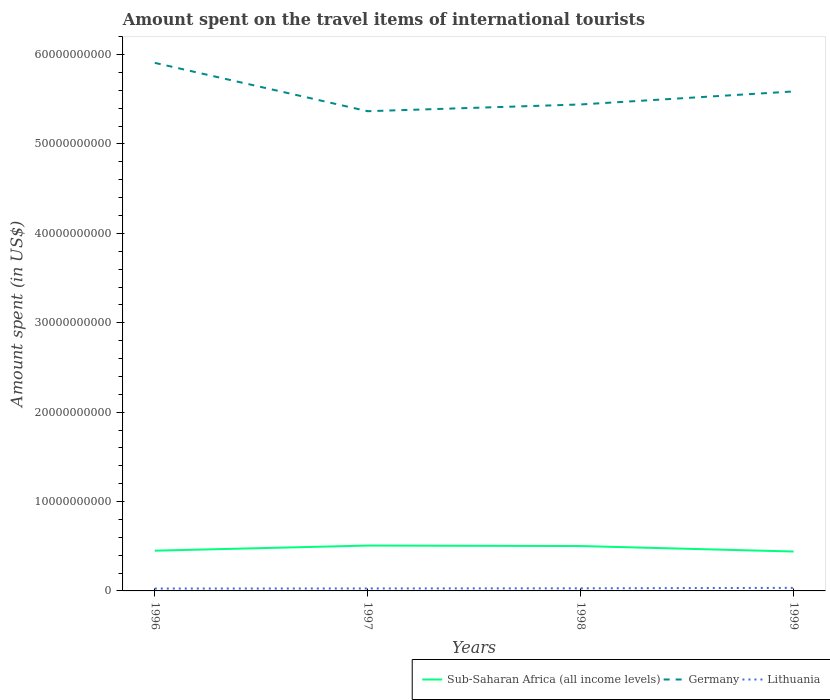Does the line corresponding to Sub-Saharan Africa (all income levels) intersect with the line corresponding to Lithuania?
Keep it short and to the point. No. Is the number of lines equal to the number of legend labels?
Keep it short and to the point. Yes. Across all years, what is the maximum amount spent on the travel items of international tourists in Sub-Saharan Africa (all income levels)?
Provide a short and direct response. 4.41e+09. What is the total amount spent on the travel items of international tourists in Germany in the graph?
Offer a terse response. 4.65e+09. What is the difference between the highest and the second highest amount spent on the travel items of international tourists in Sub-Saharan Africa (all income levels)?
Offer a terse response. 6.65e+08. Is the amount spent on the travel items of international tourists in Sub-Saharan Africa (all income levels) strictly greater than the amount spent on the travel items of international tourists in Germany over the years?
Offer a very short reply. Yes. How many lines are there?
Ensure brevity in your answer.  3. What is the title of the graph?
Give a very brief answer. Amount spent on the travel items of international tourists. What is the label or title of the Y-axis?
Your answer should be compact. Amount spent (in US$). What is the Amount spent (in US$) in Sub-Saharan Africa (all income levels) in 1996?
Keep it short and to the point. 4.50e+09. What is the Amount spent (in US$) in Germany in 1996?
Offer a terse response. 5.91e+1. What is the Amount spent (in US$) of Lithuania in 1996?
Your response must be concise. 2.66e+08. What is the Amount spent (in US$) of Sub-Saharan Africa (all income levels) in 1997?
Ensure brevity in your answer.  5.07e+09. What is the Amount spent (in US$) of Germany in 1997?
Provide a succinct answer. 5.37e+1. What is the Amount spent (in US$) in Lithuania in 1997?
Your answer should be very brief. 2.77e+08. What is the Amount spent (in US$) of Sub-Saharan Africa (all income levels) in 1998?
Provide a short and direct response. 5.02e+09. What is the Amount spent (in US$) of Germany in 1998?
Your answer should be very brief. 5.44e+1. What is the Amount spent (in US$) of Lithuania in 1998?
Keep it short and to the point. 2.92e+08. What is the Amount spent (in US$) of Sub-Saharan Africa (all income levels) in 1999?
Offer a terse response. 4.41e+09. What is the Amount spent (in US$) of Germany in 1999?
Offer a very short reply. 5.59e+1. What is the Amount spent (in US$) in Lithuania in 1999?
Ensure brevity in your answer.  3.41e+08. Across all years, what is the maximum Amount spent (in US$) of Sub-Saharan Africa (all income levels)?
Provide a short and direct response. 5.07e+09. Across all years, what is the maximum Amount spent (in US$) in Germany?
Your response must be concise. 5.91e+1. Across all years, what is the maximum Amount spent (in US$) in Lithuania?
Keep it short and to the point. 3.41e+08. Across all years, what is the minimum Amount spent (in US$) in Sub-Saharan Africa (all income levels)?
Keep it short and to the point. 4.41e+09. Across all years, what is the minimum Amount spent (in US$) in Germany?
Your answer should be compact. 5.37e+1. Across all years, what is the minimum Amount spent (in US$) of Lithuania?
Your response must be concise. 2.66e+08. What is the total Amount spent (in US$) in Sub-Saharan Africa (all income levels) in the graph?
Offer a very short reply. 1.90e+1. What is the total Amount spent (in US$) in Germany in the graph?
Give a very brief answer. 2.23e+11. What is the total Amount spent (in US$) in Lithuania in the graph?
Your answer should be compact. 1.18e+09. What is the difference between the Amount spent (in US$) of Sub-Saharan Africa (all income levels) in 1996 and that in 1997?
Provide a short and direct response. -5.72e+08. What is the difference between the Amount spent (in US$) in Germany in 1996 and that in 1997?
Keep it short and to the point. 5.41e+09. What is the difference between the Amount spent (in US$) of Lithuania in 1996 and that in 1997?
Give a very brief answer. -1.10e+07. What is the difference between the Amount spent (in US$) of Sub-Saharan Africa (all income levels) in 1996 and that in 1998?
Ensure brevity in your answer.  -5.18e+08. What is the difference between the Amount spent (in US$) of Germany in 1996 and that in 1998?
Provide a short and direct response. 4.65e+09. What is the difference between the Amount spent (in US$) of Lithuania in 1996 and that in 1998?
Make the answer very short. -2.60e+07. What is the difference between the Amount spent (in US$) of Sub-Saharan Africa (all income levels) in 1996 and that in 1999?
Offer a very short reply. 9.26e+07. What is the difference between the Amount spent (in US$) of Germany in 1996 and that in 1999?
Your answer should be compact. 3.20e+09. What is the difference between the Amount spent (in US$) of Lithuania in 1996 and that in 1999?
Ensure brevity in your answer.  -7.50e+07. What is the difference between the Amount spent (in US$) of Sub-Saharan Africa (all income levels) in 1997 and that in 1998?
Provide a short and direct response. 5.43e+07. What is the difference between the Amount spent (in US$) in Germany in 1997 and that in 1998?
Provide a succinct answer. -7.56e+08. What is the difference between the Amount spent (in US$) of Lithuania in 1997 and that in 1998?
Make the answer very short. -1.50e+07. What is the difference between the Amount spent (in US$) in Sub-Saharan Africa (all income levels) in 1997 and that in 1999?
Provide a succinct answer. 6.65e+08. What is the difference between the Amount spent (in US$) of Germany in 1997 and that in 1999?
Provide a short and direct response. -2.21e+09. What is the difference between the Amount spent (in US$) of Lithuania in 1997 and that in 1999?
Make the answer very short. -6.40e+07. What is the difference between the Amount spent (in US$) of Sub-Saharan Africa (all income levels) in 1998 and that in 1999?
Your answer should be very brief. 6.11e+08. What is the difference between the Amount spent (in US$) of Germany in 1998 and that in 1999?
Provide a succinct answer. -1.46e+09. What is the difference between the Amount spent (in US$) of Lithuania in 1998 and that in 1999?
Offer a terse response. -4.90e+07. What is the difference between the Amount spent (in US$) in Sub-Saharan Africa (all income levels) in 1996 and the Amount spent (in US$) in Germany in 1997?
Provide a succinct answer. -4.92e+1. What is the difference between the Amount spent (in US$) of Sub-Saharan Africa (all income levels) in 1996 and the Amount spent (in US$) of Lithuania in 1997?
Keep it short and to the point. 4.22e+09. What is the difference between the Amount spent (in US$) of Germany in 1996 and the Amount spent (in US$) of Lithuania in 1997?
Give a very brief answer. 5.88e+1. What is the difference between the Amount spent (in US$) in Sub-Saharan Africa (all income levels) in 1996 and the Amount spent (in US$) in Germany in 1998?
Your answer should be compact. -4.99e+1. What is the difference between the Amount spent (in US$) of Sub-Saharan Africa (all income levels) in 1996 and the Amount spent (in US$) of Lithuania in 1998?
Provide a short and direct response. 4.21e+09. What is the difference between the Amount spent (in US$) in Germany in 1996 and the Amount spent (in US$) in Lithuania in 1998?
Your response must be concise. 5.88e+1. What is the difference between the Amount spent (in US$) of Sub-Saharan Africa (all income levels) in 1996 and the Amount spent (in US$) of Germany in 1999?
Your answer should be very brief. -5.14e+1. What is the difference between the Amount spent (in US$) of Sub-Saharan Africa (all income levels) in 1996 and the Amount spent (in US$) of Lithuania in 1999?
Your answer should be compact. 4.16e+09. What is the difference between the Amount spent (in US$) in Germany in 1996 and the Amount spent (in US$) in Lithuania in 1999?
Give a very brief answer. 5.87e+1. What is the difference between the Amount spent (in US$) of Sub-Saharan Africa (all income levels) in 1997 and the Amount spent (in US$) of Germany in 1998?
Offer a terse response. -4.93e+1. What is the difference between the Amount spent (in US$) in Sub-Saharan Africa (all income levels) in 1997 and the Amount spent (in US$) in Lithuania in 1998?
Your response must be concise. 4.78e+09. What is the difference between the Amount spent (in US$) of Germany in 1997 and the Amount spent (in US$) of Lithuania in 1998?
Your response must be concise. 5.34e+1. What is the difference between the Amount spent (in US$) in Sub-Saharan Africa (all income levels) in 1997 and the Amount spent (in US$) in Germany in 1999?
Give a very brief answer. -5.08e+1. What is the difference between the Amount spent (in US$) of Sub-Saharan Africa (all income levels) in 1997 and the Amount spent (in US$) of Lithuania in 1999?
Offer a terse response. 4.73e+09. What is the difference between the Amount spent (in US$) of Germany in 1997 and the Amount spent (in US$) of Lithuania in 1999?
Your response must be concise. 5.33e+1. What is the difference between the Amount spent (in US$) in Sub-Saharan Africa (all income levels) in 1998 and the Amount spent (in US$) in Germany in 1999?
Offer a very short reply. -5.09e+1. What is the difference between the Amount spent (in US$) in Sub-Saharan Africa (all income levels) in 1998 and the Amount spent (in US$) in Lithuania in 1999?
Keep it short and to the point. 4.68e+09. What is the difference between the Amount spent (in US$) in Germany in 1998 and the Amount spent (in US$) in Lithuania in 1999?
Make the answer very short. 5.41e+1. What is the average Amount spent (in US$) of Sub-Saharan Africa (all income levels) per year?
Your answer should be very brief. 4.75e+09. What is the average Amount spent (in US$) of Germany per year?
Keep it short and to the point. 5.58e+1. What is the average Amount spent (in US$) of Lithuania per year?
Your response must be concise. 2.94e+08. In the year 1996, what is the difference between the Amount spent (in US$) of Sub-Saharan Africa (all income levels) and Amount spent (in US$) of Germany?
Your response must be concise. -5.46e+1. In the year 1996, what is the difference between the Amount spent (in US$) of Sub-Saharan Africa (all income levels) and Amount spent (in US$) of Lithuania?
Your response must be concise. 4.24e+09. In the year 1996, what is the difference between the Amount spent (in US$) of Germany and Amount spent (in US$) of Lithuania?
Ensure brevity in your answer.  5.88e+1. In the year 1997, what is the difference between the Amount spent (in US$) of Sub-Saharan Africa (all income levels) and Amount spent (in US$) of Germany?
Ensure brevity in your answer.  -4.86e+1. In the year 1997, what is the difference between the Amount spent (in US$) of Sub-Saharan Africa (all income levels) and Amount spent (in US$) of Lithuania?
Offer a terse response. 4.80e+09. In the year 1997, what is the difference between the Amount spent (in US$) of Germany and Amount spent (in US$) of Lithuania?
Ensure brevity in your answer.  5.34e+1. In the year 1998, what is the difference between the Amount spent (in US$) of Sub-Saharan Africa (all income levels) and Amount spent (in US$) of Germany?
Provide a short and direct response. -4.94e+1. In the year 1998, what is the difference between the Amount spent (in US$) of Sub-Saharan Africa (all income levels) and Amount spent (in US$) of Lithuania?
Offer a terse response. 4.73e+09. In the year 1998, what is the difference between the Amount spent (in US$) in Germany and Amount spent (in US$) in Lithuania?
Ensure brevity in your answer.  5.41e+1. In the year 1999, what is the difference between the Amount spent (in US$) of Sub-Saharan Africa (all income levels) and Amount spent (in US$) of Germany?
Offer a very short reply. -5.15e+1. In the year 1999, what is the difference between the Amount spent (in US$) in Sub-Saharan Africa (all income levels) and Amount spent (in US$) in Lithuania?
Give a very brief answer. 4.07e+09. In the year 1999, what is the difference between the Amount spent (in US$) in Germany and Amount spent (in US$) in Lithuania?
Your answer should be very brief. 5.55e+1. What is the ratio of the Amount spent (in US$) in Sub-Saharan Africa (all income levels) in 1996 to that in 1997?
Keep it short and to the point. 0.89. What is the ratio of the Amount spent (in US$) of Germany in 1996 to that in 1997?
Your response must be concise. 1.1. What is the ratio of the Amount spent (in US$) of Lithuania in 1996 to that in 1997?
Provide a succinct answer. 0.96. What is the ratio of the Amount spent (in US$) in Sub-Saharan Africa (all income levels) in 1996 to that in 1998?
Give a very brief answer. 0.9. What is the ratio of the Amount spent (in US$) in Germany in 1996 to that in 1998?
Offer a terse response. 1.09. What is the ratio of the Amount spent (in US$) in Lithuania in 1996 to that in 1998?
Offer a terse response. 0.91. What is the ratio of the Amount spent (in US$) of Germany in 1996 to that in 1999?
Make the answer very short. 1.06. What is the ratio of the Amount spent (in US$) in Lithuania in 1996 to that in 1999?
Keep it short and to the point. 0.78. What is the ratio of the Amount spent (in US$) of Sub-Saharan Africa (all income levels) in 1997 to that in 1998?
Give a very brief answer. 1.01. What is the ratio of the Amount spent (in US$) in Germany in 1997 to that in 1998?
Ensure brevity in your answer.  0.99. What is the ratio of the Amount spent (in US$) in Lithuania in 1997 to that in 1998?
Provide a succinct answer. 0.95. What is the ratio of the Amount spent (in US$) in Sub-Saharan Africa (all income levels) in 1997 to that in 1999?
Offer a terse response. 1.15. What is the ratio of the Amount spent (in US$) of Germany in 1997 to that in 1999?
Keep it short and to the point. 0.96. What is the ratio of the Amount spent (in US$) in Lithuania in 1997 to that in 1999?
Your answer should be very brief. 0.81. What is the ratio of the Amount spent (in US$) in Sub-Saharan Africa (all income levels) in 1998 to that in 1999?
Your response must be concise. 1.14. What is the ratio of the Amount spent (in US$) of Germany in 1998 to that in 1999?
Your answer should be very brief. 0.97. What is the ratio of the Amount spent (in US$) of Lithuania in 1998 to that in 1999?
Make the answer very short. 0.86. What is the difference between the highest and the second highest Amount spent (in US$) of Sub-Saharan Africa (all income levels)?
Give a very brief answer. 5.43e+07. What is the difference between the highest and the second highest Amount spent (in US$) in Germany?
Your answer should be very brief. 3.20e+09. What is the difference between the highest and the second highest Amount spent (in US$) of Lithuania?
Give a very brief answer. 4.90e+07. What is the difference between the highest and the lowest Amount spent (in US$) in Sub-Saharan Africa (all income levels)?
Keep it short and to the point. 6.65e+08. What is the difference between the highest and the lowest Amount spent (in US$) in Germany?
Make the answer very short. 5.41e+09. What is the difference between the highest and the lowest Amount spent (in US$) in Lithuania?
Your response must be concise. 7.50e+07. 